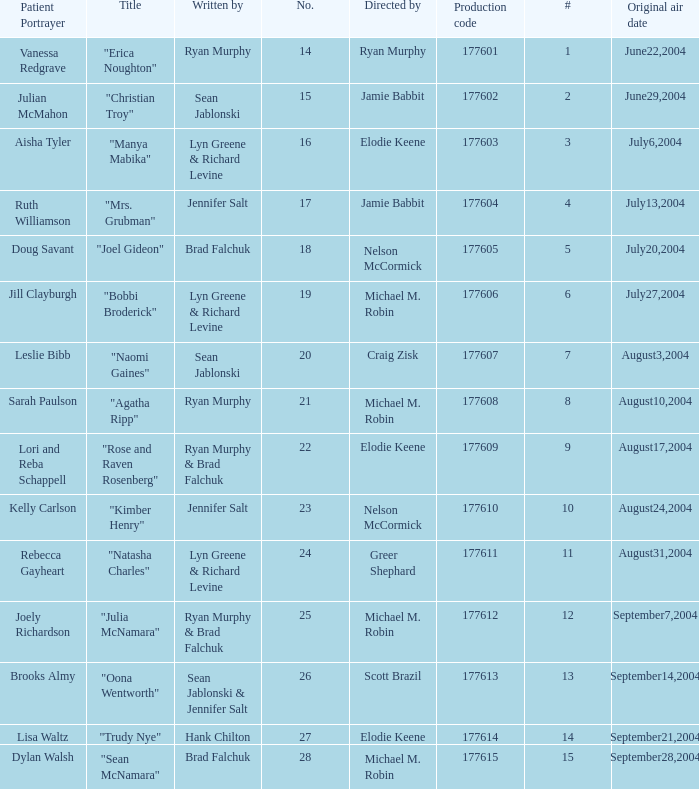Would you mind parsing the complete table? {'header': ['Patient Portrayer', 'Title', 'Written by', 'No.', 'Directed by', 'Production code', '#', 'Original air date'], 'rows': [['Vanessa Redgrave', '"Erica Noughton"', 'Ryan Murphy', '14', 'Ryan Murphy', '177601', '1', 'June22,2004'], ['Julian McMahon', '"Christian Troy"', 'Sean Jablonski', '15', 'Jamie Babbit', '177602', '2', 'June29,2004'], ['Aisha Tyler', '"Manya Mabika"', 'Lyn Greene & Richard Levine', '16', 'Elodie Keene', '177603', '3', 'July6,2004'], ['Ruth Williamson', '"Mrs. Grubman"', 'Jennifer Salt', '17', 'Jamie Babbit', '177604', '4', 'July13,2004'], ['Doug Savant', '"Joel Gideon"', 'Brad Falchuk', '18', 'Nelson McCormick', '177605', '5', 'July20,2004'], ['Jill Clayburgh', '"Bobbi Broderick"', 'Lyn Greene & Richard Levine', '19', 'Michael M. Robin', '177606', '6', 'July27,2004'], ['Leslie Bibb', '"Naomi Gaines"', 'Sean Jablonski', '20', 'Craig Zisk', '177607', '7', 'August3,2004'], ['Sarah Paulson', '"Agatha Ripp"', 'Ryan Murphy', '21', 'Michael M. Robin', '177608', '8', 'August10,2004'], ['Lori and Reba Schappell', '"Rose and Raven Rosenberg"', 'Ryan Murphy & Brad Falchuk', '22', 'Elodie Keene', '177609', '9', 'August17,2004'], ['Kelly Carlson', '"Kimber Henry"', 'Jennifer Salt', '23', 'Nelson McCormick', '177610', '10', 'August24,2004'], ['Rebecca Gayheart', '"Natasha Charles"', 'Lyn Greene & Richard Levine', '24', 'Greer Shephard', '177611', '11', 'August31,2004'], ['Joely Richardson', '"Julia McNamara"', 'Ryan Murphy & Brad Falchuk', '25', 'Michael M. Robin', '177612', '12', 'September7,2004'], ['Brooks Almy', '"Oona Wentworth"', 'Sean Jablonski & Jennifer Salt', '26', 'Scott Brazil', '177613', '13', 'September14,2004'], ['Lisa Waltz', '"Trudy Nye"', 'Hank Chilton', '27', 'Elodie Keene', '177614', '14', 'September21,2004'], ['Dylan Walsh', '"Sean McNamara"', 'Brad Falchuk', '28', 'Michael M. Robin', '177615', '15', 'September28,2004']]} What numbered episode is titled "naomi gaines"? 20.0. 